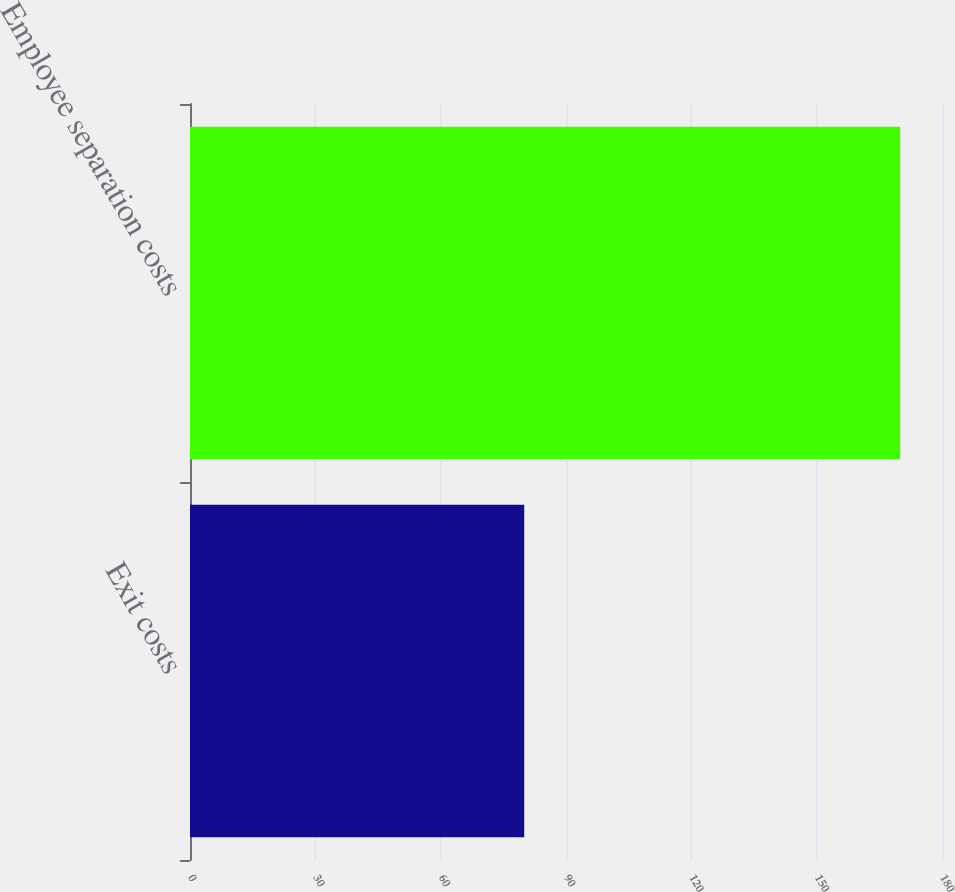Convert chart. <chart><loc_0><loc_0><loc_500><loc_500><bar_chart><fcel>Exit costs<fcel>Employee separation costs<nl><fcel>80<fcel>170<nl></chart> 